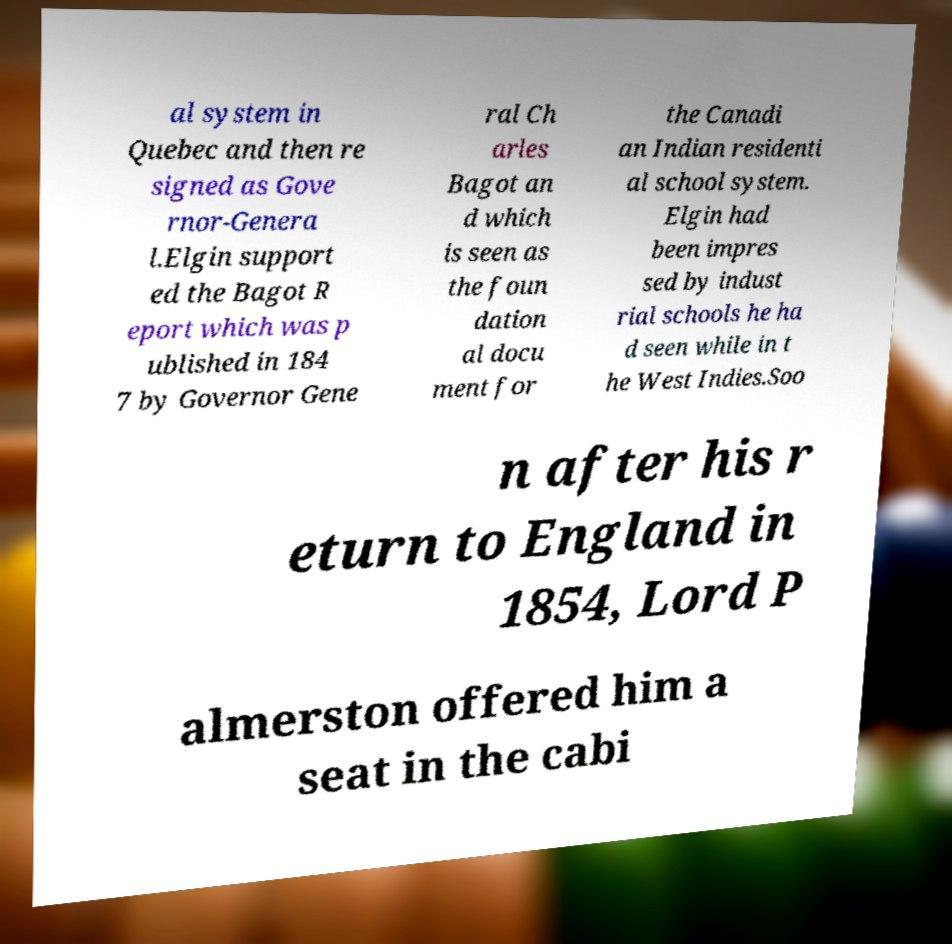For documentation purposes, I need the text within this image transcribed. Could you provide that? al system in Quebec and then re signed as Gove rnor-Genera l.Elgin support ed the Bagot R eport which was p ublished in 184 7 by Governor Gene ral Ch arles Bagot an d which is seen as the foun dation al docu ment for the Canadi an Indian residenti al school system. Elgin had been impres sed by indust rial schools he ha d seen while in t he West Indies.Soo n after his r eturn to England in 1854, Lord P almerston offered him a seat in the cabi 